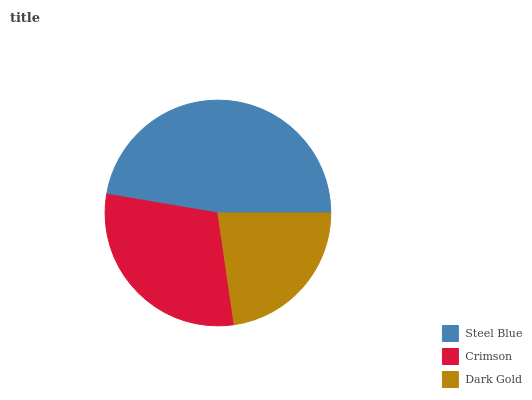Is Dark Gold the minimum?
Answer yes or no. Yes. Is Steel Blue the maximum?
Answer yes or no. Yes. Is Crimson the minimum?
Answer yes or no. No. Is Crimson the maximum?
Answer yes or no. No. Is Steel Blue greater than Crimson?
Answer yes or no. Yes. Is Crimson less than Steel Blue?
Answer yes or no. Yes. Is Crimson greater than Steel Blue?
Answer yes or no. No. Is Steel Blue less than Crimson?
Answer yes or no. No. Is Crimson the high median?
Answer yes or no. Yes. Is Crimson the low median?
Answer yes or no. Yes. Is Steel Blue the high median?
Answer yes or no. No. Is Steel Blue the low median?
Answer yes or no. No. 